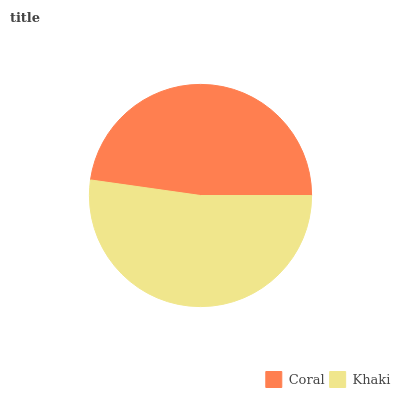Is Coral the minimum?
Answer yes or no. Yes. Is Khaki the maximum?
Answer yes or no. Yes. Is Khaki the minimum?
Answer yes or no. No. Is Khaki greater than Coral?
Answer yes or no. Yes. Is Coral less than Khaki?
Answer yes or no. Yes. Is Coral greater than Khaki?
Answer yes or no. No. Is Khaki less than Coral?
Answer yes or no. No. Is Khaki the high median?
Answer yes or no. Yes. Is Coral the low median?
Answer yes or no. Yes. Is Coral the high median?
Answer yes or no. No. Is Khaki the low median?
Answer yes or no. No. 